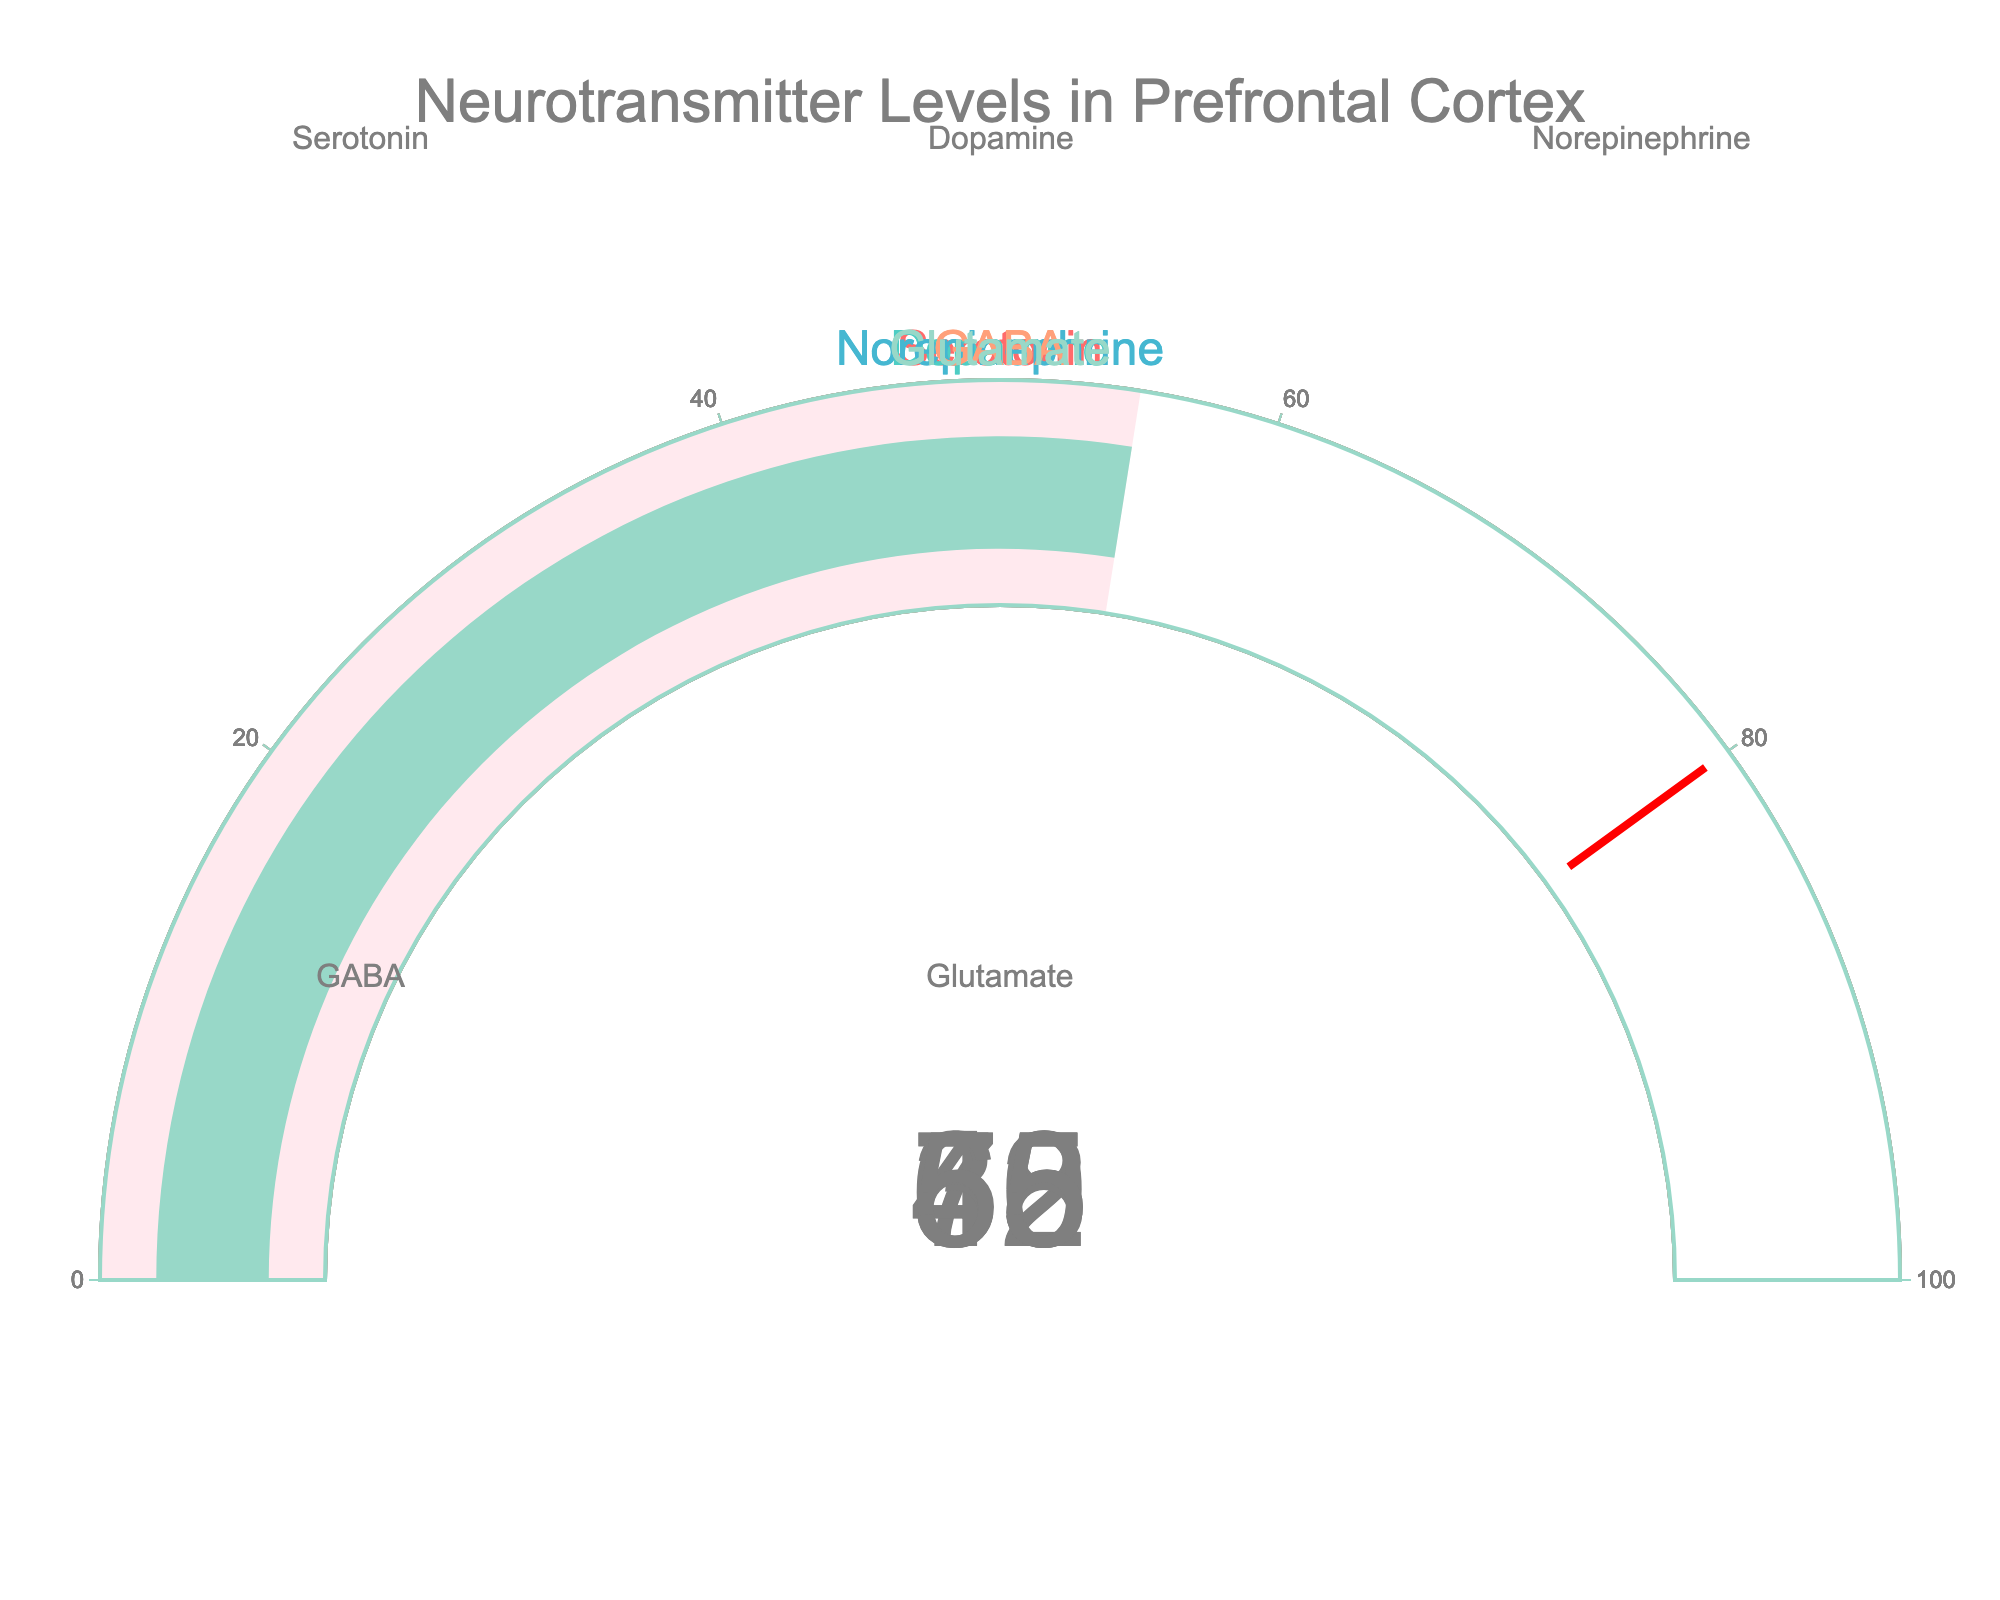What is the title of the figure? The title of the figure is written at the top and says "Neurotransmitter Levels in Prefrontal Cortex".
Answer: Neurotransmitter Levels in Prefrontal Cortex How many neurotransmitters are displayed in the figure? There is one gauge per neurotransmitter. By counting the number of gauges, we can determine that there are five neurotransmitters displayed.
Answer: Five What is the level of Serotonin? Look at the gauge with the title "Serotonin" and observe the number displayed within the gauge.
Answer: 72 Which neurotransmitter has the highest level? Compare the levels given in each gauge. The neurotransmitter with the highest numeric value is the highest. Here, Serotonin has the highest level at 72.
Answer: Serotonin What is the difference between the levels of Serotonin and Dopamine? The level of Serotonin is 72 and the level of Dopamine is 45. Subtract the level of Dopamine from the level of Serotonin: 72 - 45 = 27.
Answer: 27 Which neurotransmitter has a lower level, GABA or Glutamate? Compare the levels shown in the gauges for GABA and Glutamate. GABA is at 60, and Glutamate is at 55. Glutamate has the lower level.
Answer: Glutamate What is the average level of all neurotransmitters displayed? Add up the levels of all neurotransmitters displayed and divide by the number of neurotransmitters. (72 + 45 + 38 + 60 + 55) / 5 = 270 / 5 = 54
Answer: 54 Are any neurotransmitters at or above the threshold of 80? Look at each gauge and determine if any level displayed is 80 or higher. No neurotransmitter reaches or exceeds this level.
Answer: No What is the combined level of Dopamine and Norepinephrine? Add the levels of Dopamine and Norepinephrine: 45 (Dopamine) + 38 (Norepinephrine) = 83.
Answer: 83 